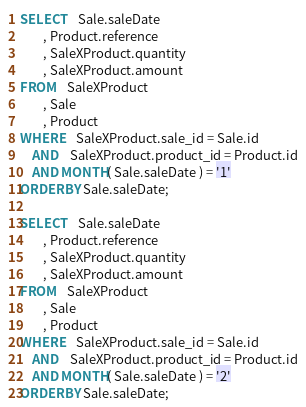<code> <loc_0><loc_0><loc_500><loc_500><_SQL_>
SELECT	Sale.saleDate
		, Product.reference
		, SaleXProduct.quantity
		, SaleXProduct.amount
FROM	SaleXProduct
		, Sale
		, Product
WHERE	SaleXProduct.sale_id = Sale.id
	AND	SaleXProduct.product_id = Product.id
	AND MONTH( Sale.saleDate ) = '1'
ORDER BY Sale.saleDate;

SELECT	Sale.saleDate
		, Product.reference
		, SaleXProduct.quantity
		, SaleXProduct.amount
FROM	SaleXProduct
		, Sale
		, Product
WHERE	SaleXProduct.sale_id = Sale.id
	AND	SaleXProduct.product_id = Product.id
	AND MONTH( Sale.saleDate ) = '2'
ORDER BY Sale.saleDate;</code> 